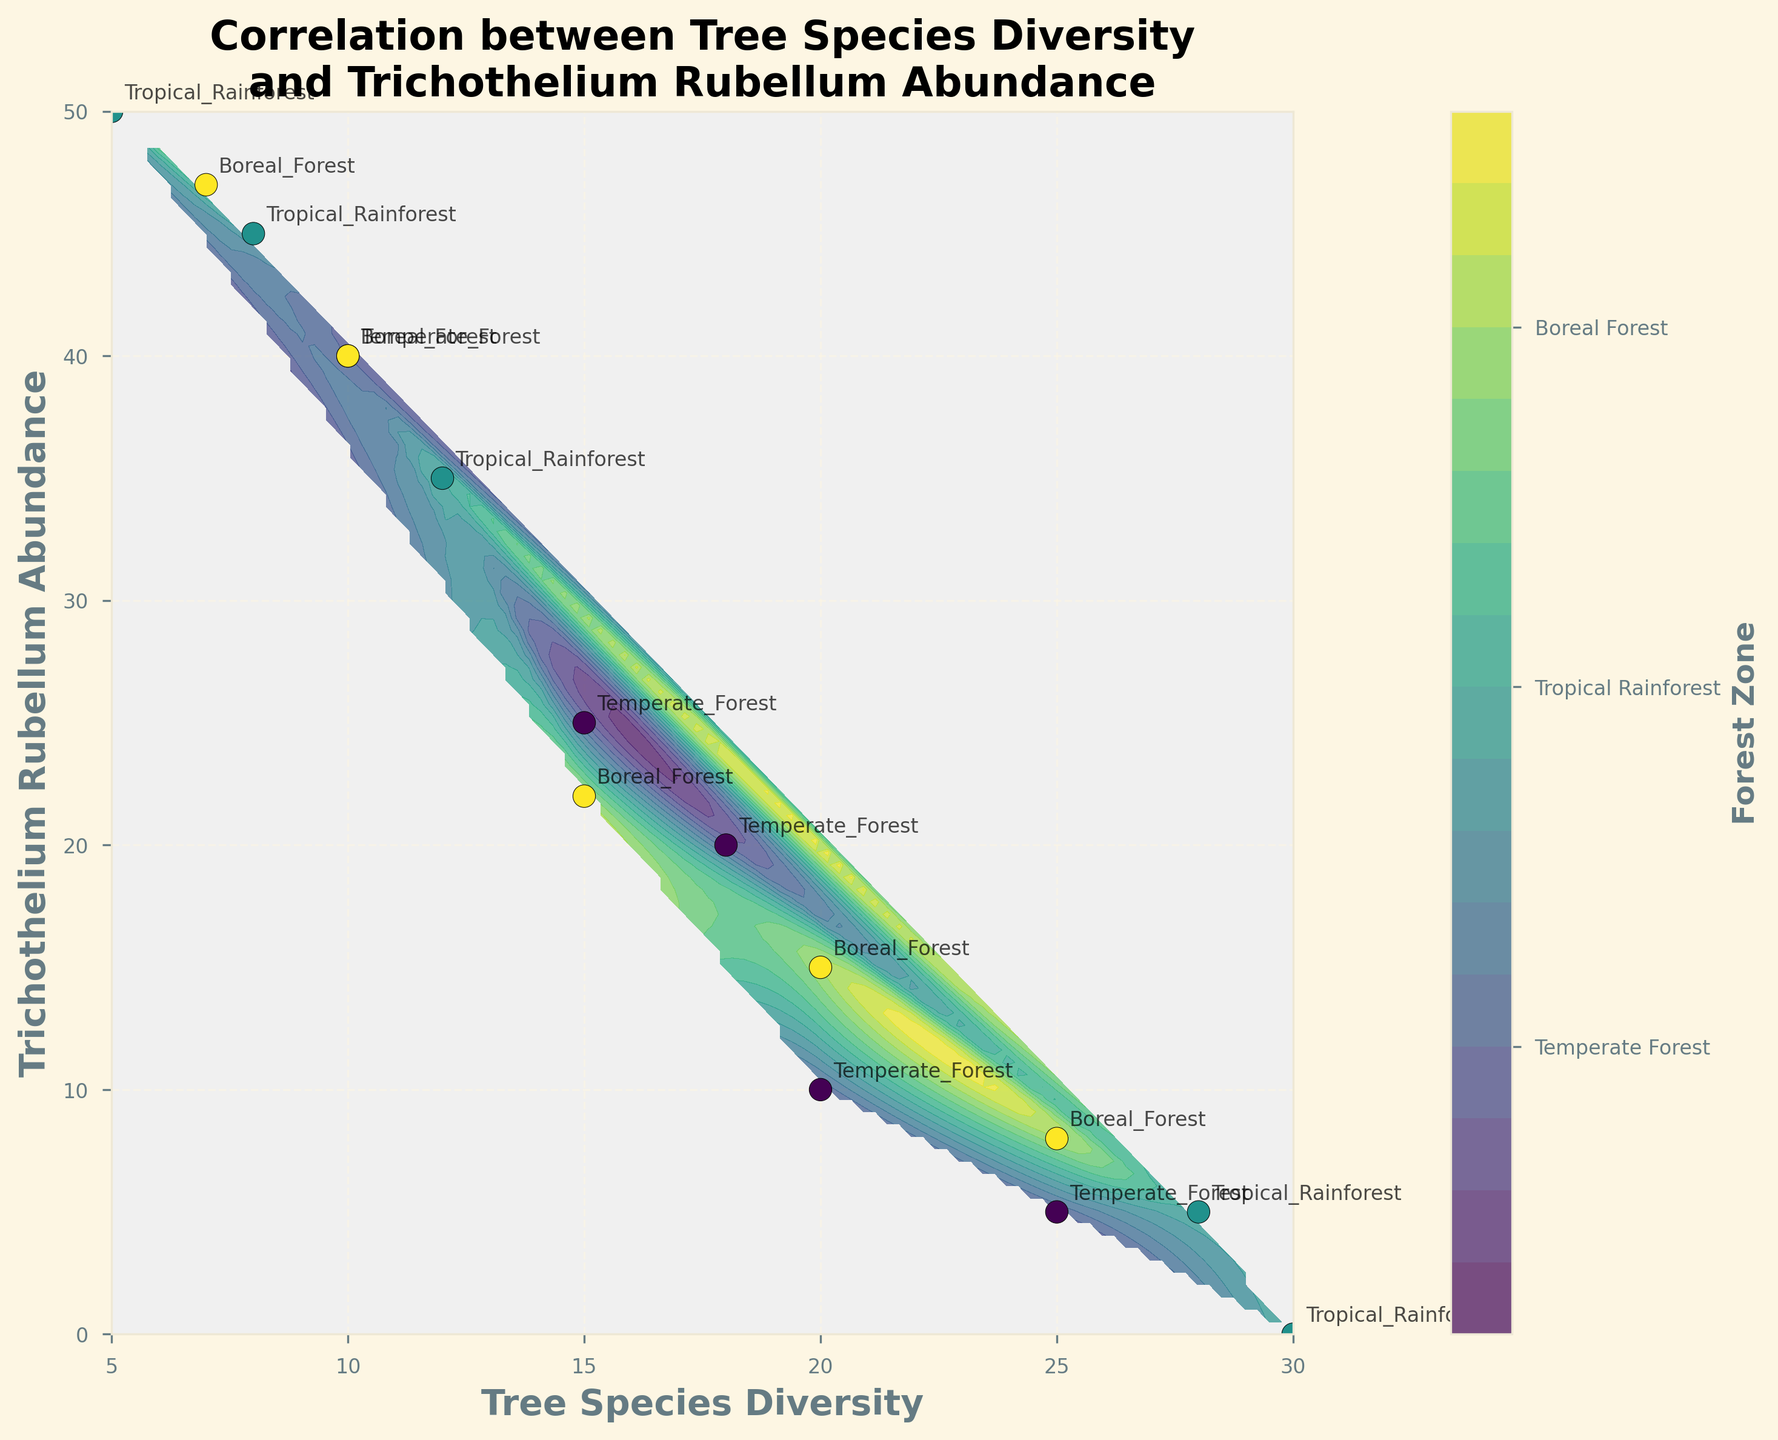How many forest zones are represented in the figure? To determine the number of forest zones, check the colorbar which indicates the zones: Temperate Forest, Tropical Rainforest, and Boreal Forest. Thus, there are three forest zones.
Answer: 3 Which forest zone shows the highest Tree Species Diversity? Check the scatter points for the highest values on the x-axis (Tree Species Diversity). The points representing Tropical Rainforest (colored differently) cluster around the higher values like 30 and 28.
Answer: Tropical Rainforest What is the Trichothelium Rubellum Abundance for the data point with 20 Tree Species Diversity in the Temperate Forest? Find the data point where Tree Species Diversity is 20 and the label indicates it's in the Temperate Forest. The corresponding y-axis value (Trichothelium Rubellum Abundance) for this point is 10.
Answer: 10 Which forest zone generally shows higher values of Trichothelium Rubellum Abundance? Observe the color of the scatter points with higher y-axis (Trichothelium Rubellum Abundance) values. The Tropical Rainforest points tend to have higher values, like 50 and 45.
Answer: Tropical Rainforest What zone appears to have the lowest overall values for Trichothelium Rubellum Abundance? Look at the contour plot and observe which color (representing zones) is present at the lowest y-axis values. The Temperate Forest zone has data points (e.g., with abundance 5 and 10) at the lowest values.
Answer: Temperate Forest Are any zones overlapping or adjacent in the contour regions? Examine the contour plot to identify if any colors blend or are adjacent between different forest zones. Some areas, particularly between Tropical Rainforest and Boreal Forest, appear adjacent or overlapping.
Answer: Yes What can be said about the Tree Species Diversity and Trichothelium Rubellum Abundance for the Boreal Forest zone? Locate scatter points marked as Boreal Forest and note their positions. These points trend toward moderate values of Tree Species Diversity (7 to 25) and lower-middle values of Trichothelium Rubellum Abundance (8 to 40).
Answer: Moderate Diversity, Lower-Middle Abundance How do the patterns of Trichothelium Rubellum Abundance vary between Temperate and Tropical Rainforests? Compare the scatter points and contours for both zones. Tropical Rainforests have higher Abundance values clustering around 50, whereas Temperate Forests show lower values mainly below 40.
Answer: Tropical Rainforests higher, Temperate lower 